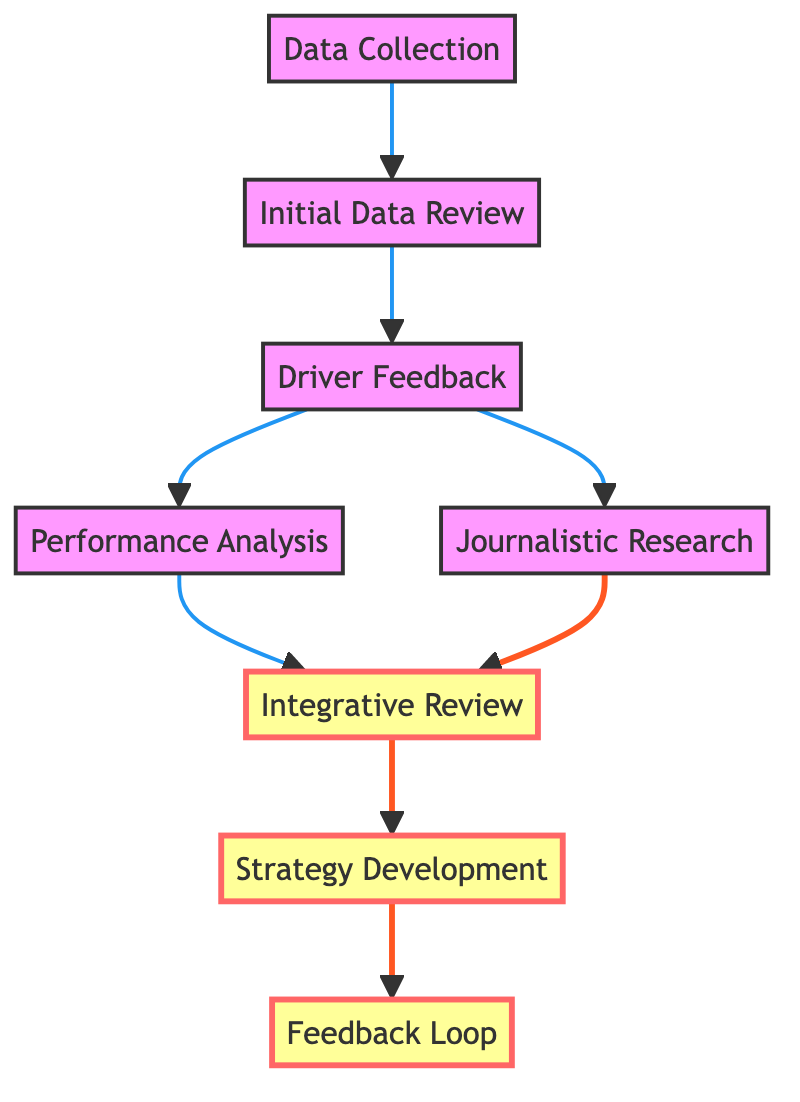What is the first step in the workflow? The first element in the flow chart is "Data Collection," which indicates the initial action taken in the workflow.
Answer: Data Collection How many total nodes are in the workflow? By counting all the distinct steps listed in the flow chart, we find there are eight nodes, covering each part of the process.
Answer: 8 What step follows "Initial Data Review"? In the flow, "Driver Feedback" directly follows "Initial Data Review," indicating the next stage that occurs after reviewing the data.
Answer: Driver Feedback Which two steps lead to "Integrative Review"? Both "Performance Analysis" and "Journalistic Research" provide information that is required for the "Integrative Review," showing that insights from both paths contribute to a combined assessment.
Answer: Performance Analysis and Journalistic Research What is the last step of the workflow? The last node in the flow chart is "Feedback Loop," which represents the final action taken after strategies have been developed based on the integrated insights.
Answer: Feedback Loop Explain the relationship between "Driver Feedback" and "Performance Analysis." "Driver Feedback" is a prerequisite for "Performance Analysis," as the driver's insights and experiences need to be gathered first to enhance the analysis of performance metrics derived from the telemetry data.
Answer: Driver Feedback leads to Performance Analysis Which step combines previous analyses into a single assessment? The "Integrative Review" combines both the performance analysis and journalistic research, integrating multiple perspectives to form a comprehensive overview of the race.
Answer: Integrative Review What is the common dependency for "Performance Analysis" and "Journalistic Research"? Both steps depend on "Driver Feedback," indicating that insights from the driver are crucial to inform both the analysis of performance metrics and the collection of additional insights.
Answer: Driver Feedback What follows after "Strategy Development"? The next step occurring after "Strategy Development" is "Feedback Loop," where insights and strategies are communicated back to the driver and the team.
Answer: Feedback Loop 